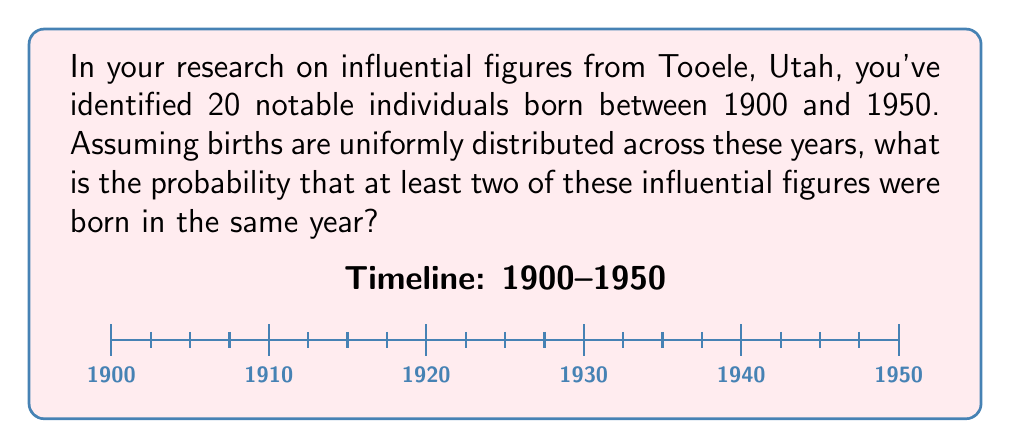Teach me how to tackle this problem. Let's approach this step-by-step using the complementary event:

1) First, let's calculate the probability that all 20 people were born in different years.

2) There are 51 possible years (1900 to 1950, inclusive).

3) For the first person, we have 51 choices. For the second, we have 50, and so on.

4) The probability of all being born in different years is:

   $$P(\text{all different}) = \frac{51 \cdot 50 \cdot 49 \cdot ... \cdot 32}{51^{20}}$$

5) This can be written more compactly using the falling factorial notation:

   $$P(\text{all different}) = \frac{51^{\underline{20}}}{51^{20}}$$

6) The probability we're looking for is the complement of this:

   $$P(\text{at least two same}) = 1 - P(\text{all different})$$

7) Calculating this:

   $$P(\text{at least two same}) = 1 - \frac{51^{\underline{20}}}{51^{20}}$$

8) Using a calculator or computer to evaluate this:

   $$P(\text{at least two same}) \approx 0.9999999999999999$$

9) This is extremely close to 1, indicating it's almost certain that at least two influential figures were born in the same year.
Answer: $1 - \frac{51^{\underline{20}}}{51^{20}} \approx 0.9999999999999999$ 